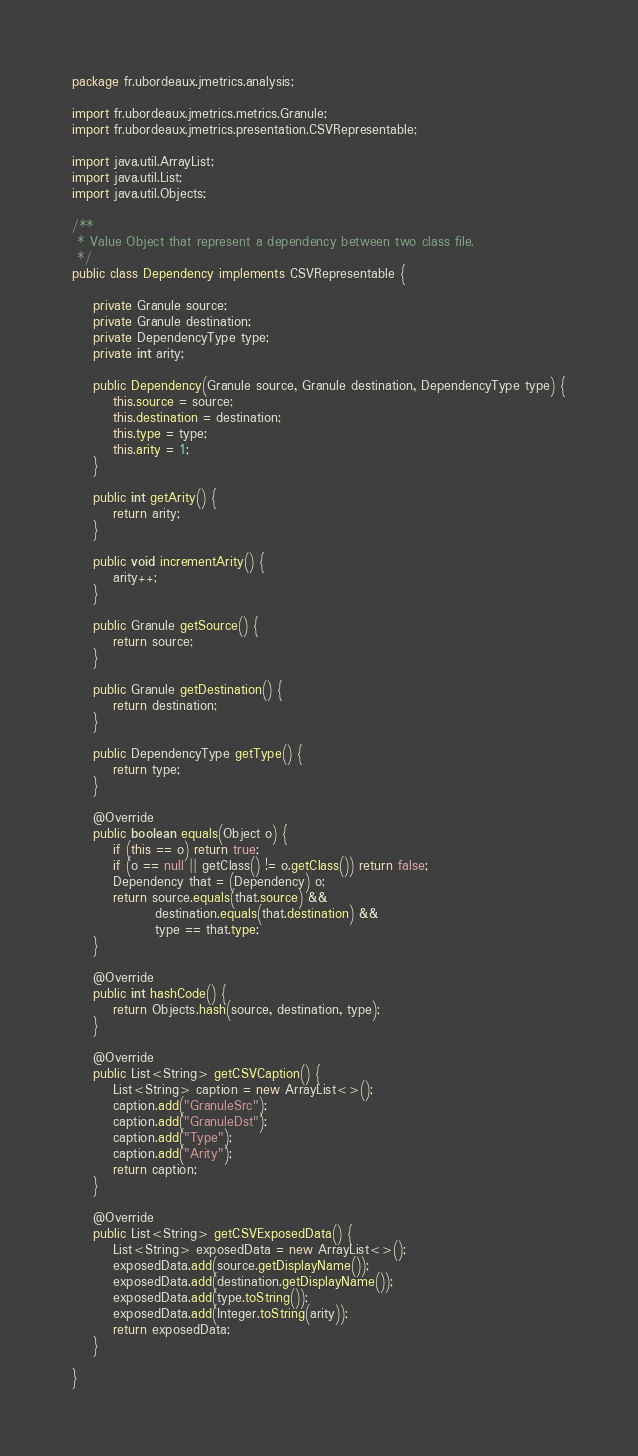Convert code to text. <code><loc_0><loc_0><loc_500><loc_500><_Java_>package fr.ubordeaux.jmetrics.analysis;

import fr.ubordeaux.jmetrics.metrics.Granule;
import fr.ubordeaux.jmetrics.presentation.CSVRepresentable;

import java.util.ArrayList;
import java.util.List;
import java.util.Objects;

/**
 * Value Object that represent a dependency between two class file.
 */
public class Dependency implements CSVRepresentable {

    private Granule source;
    private Granule destination;
    private DependencyType type;
    private int arity;

    public Dependency(Granule source, Granule destination, DependencyType type) {
        this.source = source;
        this.destination = destination;
        this.type = type;
        this.arity = 1;
    }

    public int getArity() {
        return arity;
    }

    public void incrementArity() {
        arity++;
    }

    public Granule getSource() {
        return source;
    }

    public Granule getDestination() {
        return destination;
    }

    public DependencyType getType() {
        return type;
    }

    @Override
    public boolean equals(Object o) {
        if (this == o) return true;
        if (o == null || getClass() != o.getClass()) return false;
        Dependency that = (Dependency) o;
        return source.equals(that.source) &&
                destination.equals(that.destination) &&
                type == that.type;
    }

    @Override
    public int hashCode() {
        return Objects.hash(source, destination, type);
    }

    @Override
    public List<String> getCSVCaption() {
        List<String> caption = new ArrayList<>();
        caption.add("GranuleSrc");
        caption.add("GranuleDst");
        caption.add("Type");
        caption.add("Arity");
        return caption;
    }

    @Override
    public List<String> getCSVExposedData() {
        List<String> exposedData = new ArrayList<>();
        exposedData.add(source.getDisplayName());
        exposedData.add(destination.getDisplayName());
        exposedData.add(type.toString());
        exposedData.add(Integer.toString(arity));
        return exposedData;
    }

}
</code> 